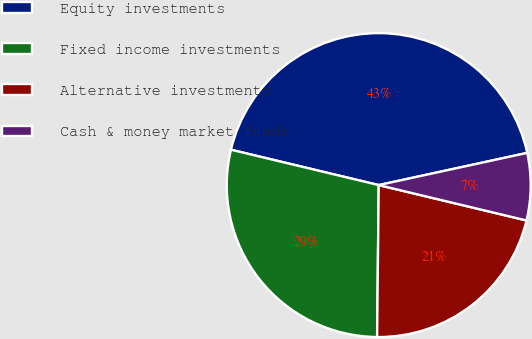Convert chart to OTSL. <chart><loc_0><loc_0><loc_500><loc_500><pie_chart><fcel>Equity investments<fcel>Fixed income investments<fcel>Alternative investments<fcel>Cash & money market funds<nl><fcel>42.86%<fcel>28.57%<fcel>21.43%<fcel>7.14%<nl></chart> 